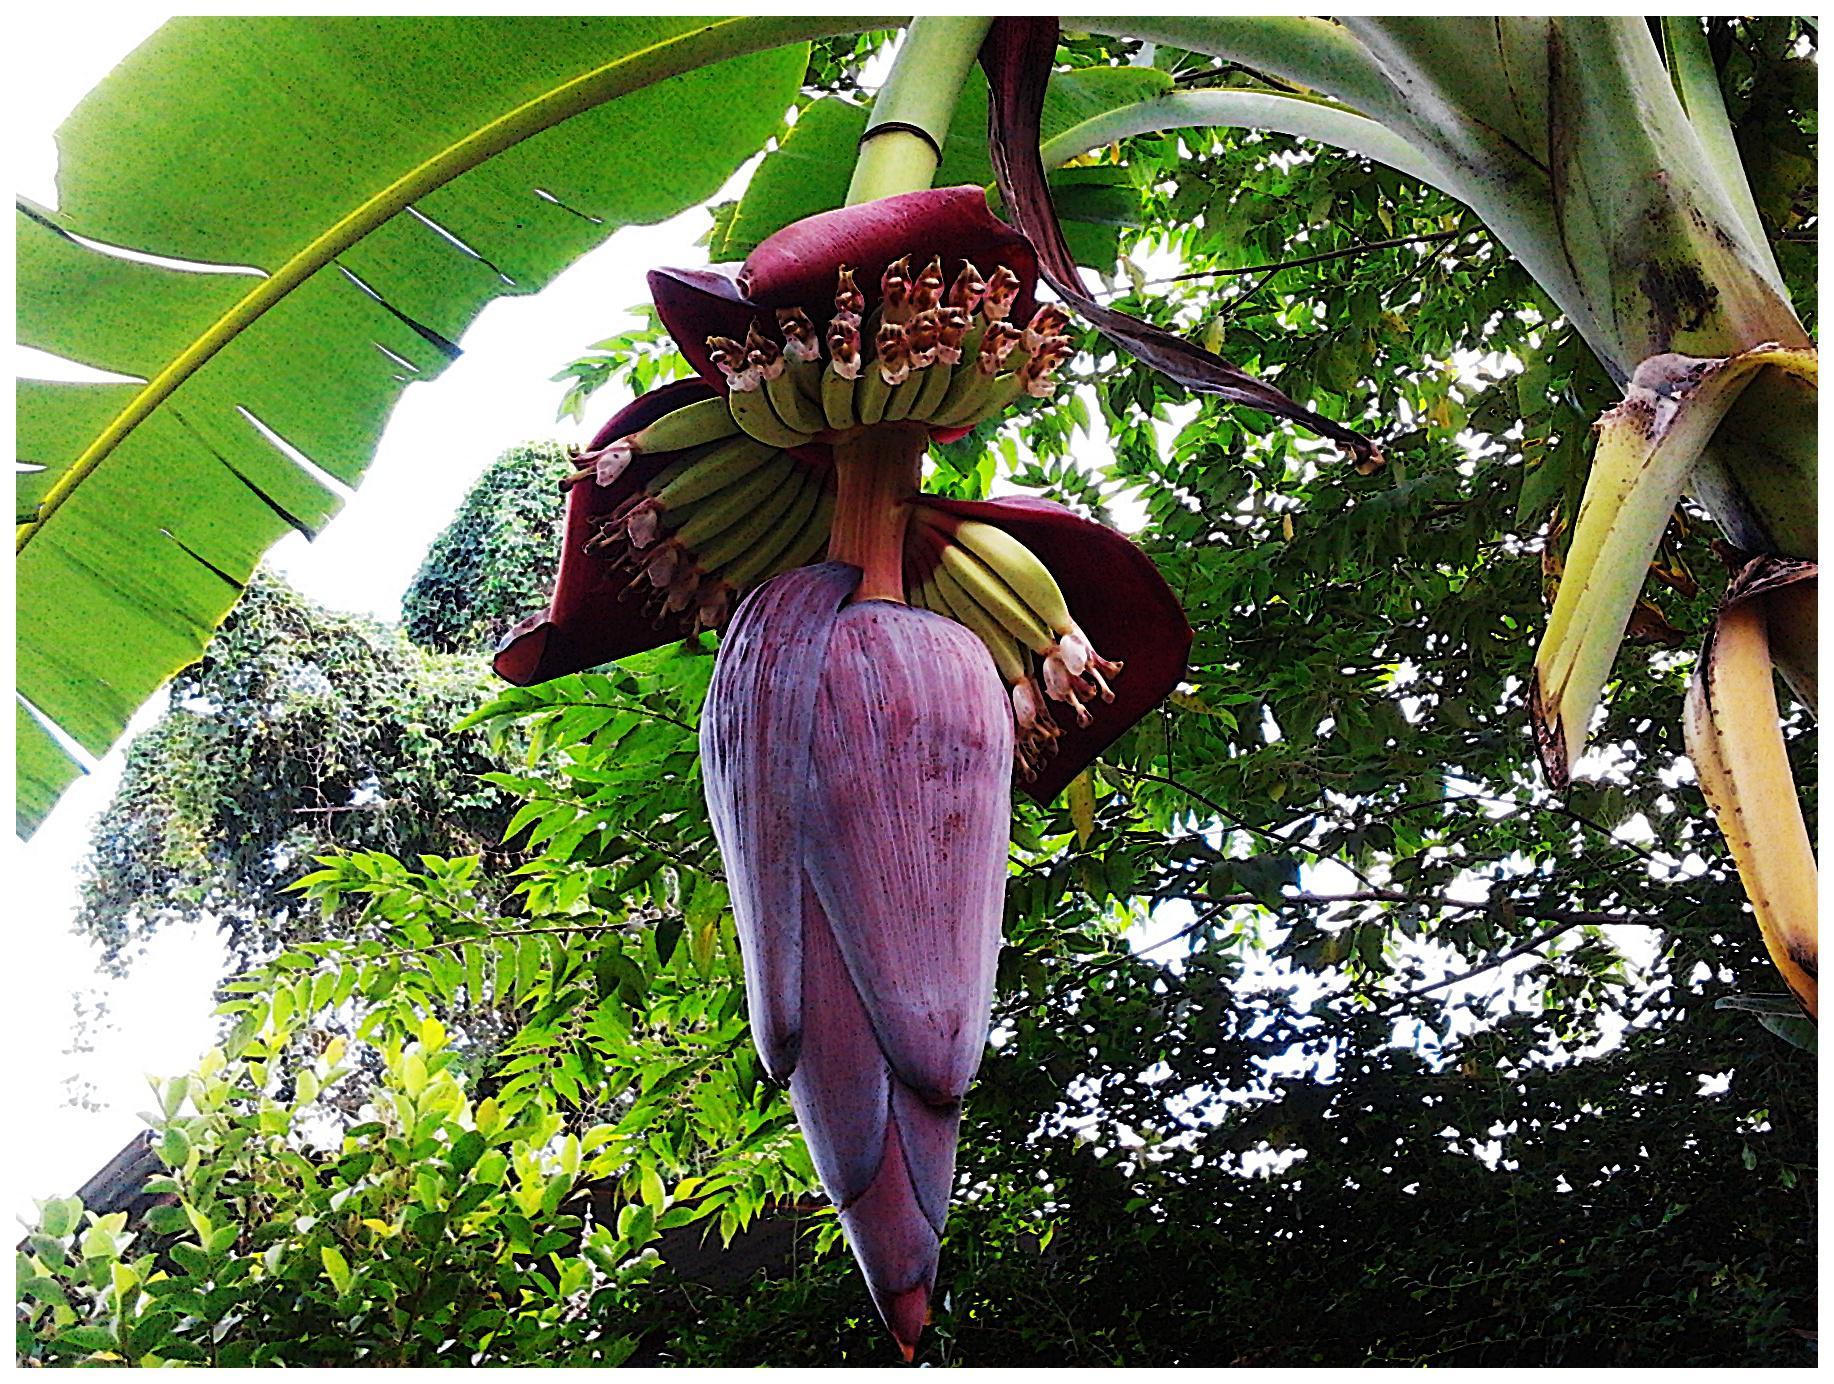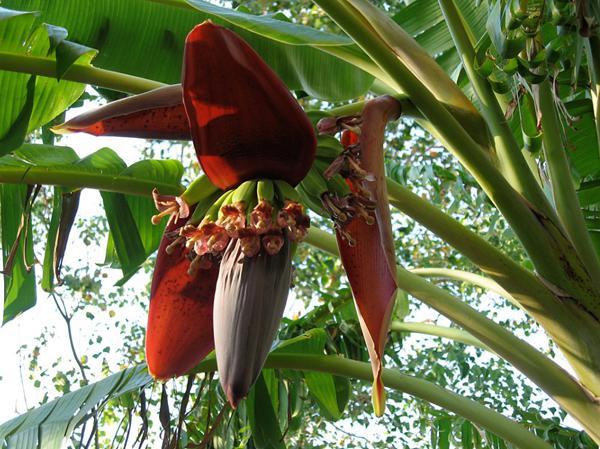The first image is the image on the left, the second image is the image on the right. For the images shown, is this caption "The dark red undersides of multiple purple petals on a giant bulb that descends from a stalk are visible in each image." true? Answer yes or no. Yes. The first image is the image on the left, the second image is the image on the right. Examine the images to the left and right. Is the description "In the image to the right, the banana flower is purple." accurate? Answer yes or no. No. 